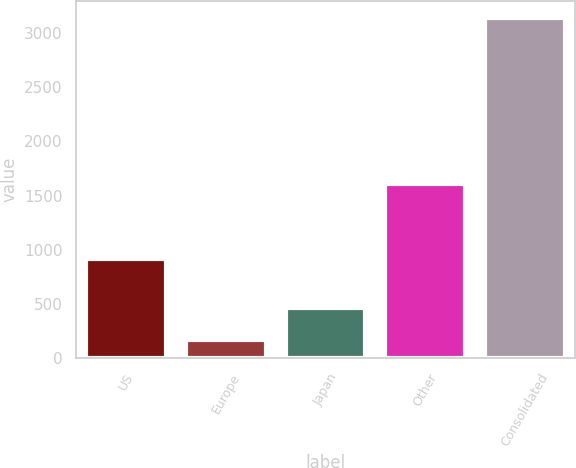Convert chart to OTSL. <chart><loc_0><loc_0><loc_500><loc_500><bar_chart><fcel>US<fcel>Europe<fcel>Japan<fcel>Other<fcel>Consolidated<nl><fcel>912<fcel>171<fcel>467.4<fcel>1603<fcel>3135<nl></chart> 